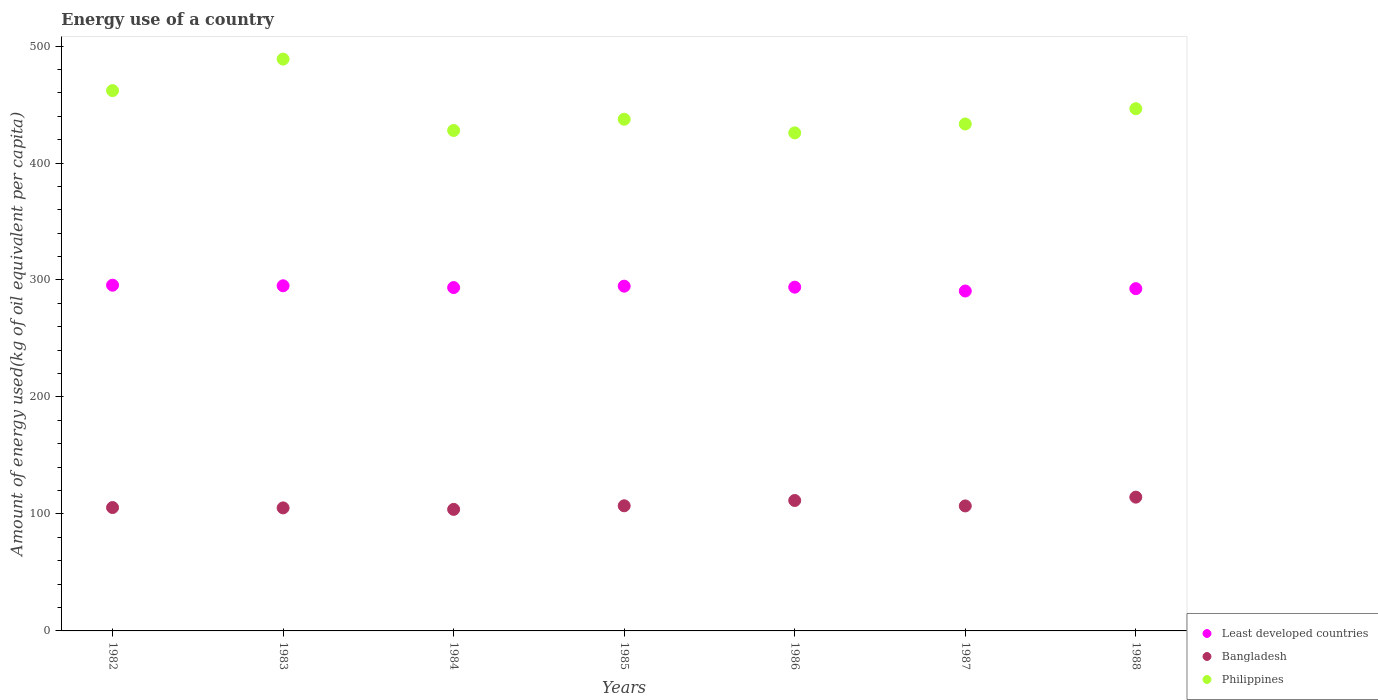How many different coloured dotlines are there?
Offer a terse response. 3. What is the amount of energy used in in Least developed countries in 1985?
Your answer should be very brief. 294.71. Across all years, what is the maximum amount of energy used in in Philippines?
Keep it short and to the point. 488.84. Across all years, what is the minimum amount of energy used in in Least developed countries?
Offer a very short reply. 290.58. In which year was the amount of energy used in in Bangladesh minimum?
Your answer should be compact. 1984. What is the total amount of energy used in in Philippines in the graph?
Provide a short and direct response. 3121.52. What is the difference between the amount of energy used in in Bangladesh in 1982 and that in 1985?
Make the answer very short. -1.5. What is the difference between the amount of energy used in in Philippines in 1988 and the amount of energy used in in Bangladesh in 1983?
Give a very brief answer. 341.26. What is the average amount of energy used in in Bangladesh per year?
Offer a terse response. 107.74. In the year 1984, what is the difference between the amount of energy used in in Bangladesh and amount of energy used in in Philippines?
Your answer should be very brief. -323.91. In how many years, is the amount of energy used in in Bangladesh greater than 320 kg?
Make the answer very short. 0. What is the ratio of the amount of energy used in in Least developed countries in 1983 to that in 1985?
Offer a terse response. 1. Is the difference between the amount of energy used in in Bangladesh in 1987 and 1988 greater than the difference between the amount of energy used in in Philippines in 1987 and 1988?
Keep it short and to the point. Yes. What is the difference between the highest and the second highest amount of energy used in in Bangladesh?
Provide a short and direct response. 2.87. What is the difference between the highest and the lowest amount of energy used in in Least developed countries?
Offer a very short reply. 4.97. Is it the case that in every year, the sum of the amount of energy used in in Bangladesh and amount of energy used in in Least developed countries  is greater than the amount of energy used in in Philippines?
Your response must be concise. No. Does the amount of energy used in in Least developed countries monotonically increase over the years?
Keep it short and to the point. No. How many years are there in the graph?
Keep it short and to the point. 7. What is the difference between two consecutive major ticks on the Y-axis?
Your response must be concise. 100. Are the values on the major ticks of Y-axis written in scientific E-notation?
Provide a succinct answer. No. How many legend labels are there?
Ensure brevity in your answer.  3. What is the title of the graph?
Provide a short and direct response. Energy use of a country. What is the label or title of the X-axis?
Make the answer very short. Years. What is the label or title of the Y-axis?
Your answer should be very brief. Amount of energy used(kg of oil equivalent per capita). What is the Amount of energy used(kg of oil equivalent per capita) of Least developed countries in 1982?
Ensure brevity in your answer.  295.55. What is the Amount of energy used(kg of oil equivalent per capita) of Bangladesh in 1982?
Your answer should be compact. 105.47. What is the Amount of energy used(kg of oil equivalent per capita) of Philippines in 1982?
Provide a succinct answer. 461.89. What is the Amount of energy used(kg of oil equivalent per capita) of Least developed countries in 1983?
Offer a very short reply. 295.06. What is the Amount of energy used(kg of oil equivalent per capita) of Bangladesh in 1983?
Ensure brevity in your answer.  105.17. What is the Amount of energy used(kg of oil equivalent per capita) in Philippines in 1983?
Provide a short and direct response. 488.84. What is the Amount of energy used(kg of oil equivalent per capita) of Least developed countries in 1984?
Offer a terse response. 293.51. What is the Amount of energy used(kg of oil equivalent per capita) in Bangladesh in 1984?
Provide a short and direct response. 103.9. What is the Amount of energy used(kg of oil equivalent per capita) in Philippines in 1984?
Ensure brevity in your answer.  427.81. What is the Amount of energy used(kg of oil equivalent per capita) in Least developed countries in 1985?
Your response must be concise. 294.71. What is the Amount of energy used(kg of oil equivalent per capita) in Bangladesh in 1985?
Ensure brevity in your answer.  106.97. What is the Amount of energy used(kg of oil equivalent per capita) in Philippines in 1985?
Make the answer very short. 437.41. What is the Amount of energy used(kg of oil equivalent per capita) of Least developed countries in 1986?
Offer a very short reply. 293.86. What is the Amount of energy used(kg of oil equivalent per capita) in Bangladesh in 1986?
Your response must be concise. 111.49. What is the Amount of energy used(kg of oil equivalent per capita) of Philippines in 1986?
Your answer should be very brief. 425.77. What is the Amount of energy used(kg of oil equivalent per capita) in Least developed countries in 1987?
Your answer should be very brief. 290.58. What is the Amount of energy used(kg of oil equivalent per capita) of Bangladesh in 1987?
Your response must be concise. 106.85. What is the Amount of energy used(kg of oil equivalent per capita) in Philippines in 1987?
Your response must be concise. 433.36. What is the Amount of energy used(kg of oil equivalent per capita) in Least developed countries in 1988?
Offer a very short reply. 292.6. What is the Amount of energy used(kg of oil equivalent per capita) in Bangladesh in 1988?
Ensure brevity in your answer.  114.36. What is the Amount of energy used(kg of oil equivalent per capita) in Philippines in 1988?
Provide a short and direct response. 446.44. Across all years, what is the maximum Amount of energy used(kg of oil equivalent per capita) of Least developed countries?
Offer a terse response. 295.55. Across all years, what is the maximum Amount of energy used(kg of oil equivalent per capita) of Bangladesh?
Provide a succinct answer. 114.36. Across all years, what is the maximum Amount of energy used(kg of oil equivalent per capita) in Philippines?
Your response must be concise. 488.84. Across all years, what is the minimum Amount of energy used(kg of oil equivalent per capita) in Least developed countries?
Your answer should be very brief. 290.58. Across all years, what is the minimum Amount of energy used(kg of oil equivalent per capita) of Bangladesh?
Provide a short and direct response. 103.9. Across all years, what is the minimum Amount of energy used(kg of oil equivalent per capita) of Philippines?
Your answer should be very brief. 425.77. What is the total Amount of energy used(kg of oil equivalent per capita) in Least developed countries in the graph?
Your answer should be very brief. 2055.87. What is the total Amount of energy used(kg of oil equivalent per capita) in Bangladesh in the graph?
Make the answer very short. 754.21. What is the total Amount of energy used(kg of oil equivalent per capita) of Philippines in the graph?
Offer a very short reply. 3121.52. What is the difference between the Amount of energy used(kg of oil equivalent per capita) in Least developed countries in 1982 and that in 1983?
Offer a terse response. 0.5. What is the difference between the Amount of energy used(kg of oil equivalent per capita) of Bangladesh in 1982 and that in 1983?
Ensure brevity in your answer.  0.3. What is the difference between the Amount of energy used(kg of oil equivalent per capita) of Philippines in 1982 and that in 1983?
Offer a terse response. -26.95. What is the difference between the Amount of energy used(kg of oil equivalent per capita) in Least developed countries in 1982 and that in 1984?
Provide a succinct answer. 2.04. What is the difference between the Amount of energy used(kg of oil equivalent per capita) of Bangladesh in 1982 and that in 1984?
Provide a succinct answer. 1.57. What is the difference between the Amount of energy used(kg of oil equivalent per capita) in Philippines in 1982 and that in 1984?
Provide a succinct answer. 34.08. What is the difference between the Amount of energy used(kg of oil equivalent per capita) in Least developed countries in 1982 and that in 1985?
Give a very brief answer. 0.84. What is the difference between the Amount of energy used(kg of oil equivalent per capita) in Bangladesh in 1982 and that in 1985?
Ensure brevity in your answer.  -1.5. What is the difference between the Amount of energy used(kg of oil equivalent per capita) of Philippines in 1982 and that in 1985?
Make the answer very short. 24.48. What is the difference between the Amount of energy used(kg of oil equivalent per capita) in Least developed countries in 1982 and that in 1986?
Provide a succinct answer. 1.69. What is the difference between the Amount of energy used(kg of oil equivalent per capita) in Bangladesh in 1982 and that in 1986?
Your answer should be compact. -6.02. What is the difference between the Amount of energy used(kg of oil equivalent per capita) in Philippines in 1982 and that in 1986?
Provide a succinct answer. 36.12. What is the difference between the Amount of energy used(kg of oil equivalent per capita) of Least developed countries in 1982 and that in 1987?
Provide a succinct answer. 4.97. What is the difference between the Amount of energy used(kg of oil equivalent per capita) in Bangladesh in 1982 and that in 1987?
Keep it short and to the point. -1.38. What is the difference between the Amount of energy used(kg of oil equivalent per capita) in Philippines in 1982 and that in 1987?
Provide a succinct answer. 28.53. What is the difference between the Amount of energy used(kg of oil equivalent per capita) in Least developed countries in 1982 and that in 1988?
Provide a short and direct response. 2.95. What is the difference between the Amount of energy used(kg of oil equivalent per capita) of Bangladesh in 1982 and that in 1988?
Offer a terse response. -8.89. What is the difference between the Amount of energy used(kg of oil equivalent per capita) of Philippines in 1982 and that in 1988?
Keep it short and to the point. 15.46. What is the difference between the Amount of energy used(kg of oil equivalent per capita) of Least developed countries in 1983 and that in 1984?
Keep it short and to the point. 1.54. What is the difference between the Amount of energy used(kg of oil equivalent per capita) in Bangladesh in 1983 and that in 1984?
Give a very brief answer. 1.27. What is the difference between the Amount of energy used(kg of oil equivalent per capita) in Philippines in 1983 and that in 1984?
Your answer should be very brief. 61.03. What is the difference between the Amount of energy used(kg of oil equivalent per capita) in Least developed countries in 1983 and that in 1985?
Give a very brief answer. 0.34. What is the difference between the Amount of energy used(kg of oil equivalent per capita) of Bangladesh in 1983 and that in 1985?
Ensure brevity in your answer.  -1.8. What is the difference between the Amount of energy used(kg of oil equivalent per capita) of Philippines in 1983 and that in 1985?
Keep it short and to the point. 51.42. What is the difference between the Amount of energy used(kg of oil equivalent per capita) in Least developed countries in 1983 and that in 1986?
Offer a terse response. 1.19. What is the difference between the Amount of energy used(kg of oil equivalent per capita) of Bangladesh in 1983 and that in 1986?
Offer a very short reply. -6.32. What is the difference between the Amount of energy used(kg of oil equivalent per capita) of Philippines in 1983 and that in 1986?
Provide a succinct answer. 63.07. What is the difference between the Amount of energy used(kg of oil equivalent per capita) of Least developed countries in 1983 and that in 1987?
Keep it short and to the point. 4.48. What is the difference between the Amount of energy used(kg of oil equivalent per capita) in Bangladesh in 1983 and that in 1987?
Make the answer very short. -1.68. What is the difference between the Amount of energy used(kg of oil equivalent per capita) of Philippines in 1983 and that in 1987?
Give a very brief answer. 55.48. What is the difference between the Amount of energy used(kg of oil equivalent per capita) in Least developed countries in 1983 and that in 1988?
Give a very brief answer. 2.45. What is the difference between the Amount of energy used(kg of oil equivalent per capita) of Bangladesh in 1983 and that in 1988?
Provide a short and direct response. -9.19. What is the difference between the Amount of energy used(kg of oil equivalent per capita) of Philippines in 1983 and that in 1988?
Your answer should be very brief. 42.4. What is the difference between the Amount of energy used(kg of oil equivalent per capita) in Least developed countries in 1984 and that in 1985?
Keep it short and to the point. -1.2. What is the difference between the Amount of energy used(kg of oil equivalent per capita) of Bangladesh in 1984 and that in 1985?
Make the answer very short. -3.07. What is the difference between the Amount of energy used(kg of oil equivalent per capita) of Philippines in 1984 and that in 1985?
Provide a short and direct response. -9.6. What is the difference between the Amount of energy used(kg of oil equivalent per capita) in Least developed countries in 1984 and that in 1986?
Keep it short and to the point. -0.35. What is the difference between the Amount of energy used(kg of oil equivalent per capita) of Bangladesh in 1984 and that in 1986?
Make the answer very short. -7.59. What is the difference between the Amount of energy used(kg of oil equivalent per capita) of Philippines in 1984 and that in 1986?
Offer a very short reply. 2.04. What is the difference between the Amount of energy used(kg of oil equivalent per capita) of Least developed countries in 1984 and that in 1987?
Ensure brevity in your answer.  2.94. What is the difference between the Amount of energy used(kg of oil equivalent per capita) of Bangladesh in 1984 and that in 1987?
Provide a succinct answer. -2.95. What is the difference between the Amount of energy used(kg of oil equivalent per capita) of Philippines in 1984 and that in 1987?
Your answer should be very brief. -5.55. What is the difference between the Amount of energy used(kg of oil equivalent per capita) of Least developed countries in 1984 and that in 1988?
Make the answer very short. 0.91. What is the difference between the Amount of energy used(kg of oil equivalent per capita) in Bangladesh in 1984 and that in 1988?
Provide a short and direct response. -10.46. What is the difference between the Amount of energy used(kg of oil equivalent per capita) in Philippines in 1984 and that in 1988?
Give a very brief answer. -18.62. What is the difference between the Amount of energy used(kg of oil equivalent per capita) of Least developed countries in 1985 and that in 1986?
Keep it short and to the point. 0.85. What is the difference between the Amount of energy used(kg of oil equivalent per capita) in Bangladesh in 1985 and that in 1986?
Provide a succinct answer. -4.53. What is the difference between the Amount of energy used(kg of oil equivalent per capita) in Philippines in 1985 and that in 1986?
Provide a short and direct response. 11.64. What is the difference between the Amount of energy used(kg of oil equivalent per capita) in Least developed countries in 1985 and that in 1987?
Make the answer very short. 4.14. What is the difference between the Amount of energy used(kg of oil equivalent per capita) of Bangladesh in 1985 and that in 1987?
Offer a very short reply. 0.12. What is the difference between the Amount of energy used(kg of oil equivalent per capita) in Philippines in 1985 and that in 1987?
Provide a succinct answer. 4.06. What is the difference between the Amount of energy used(kg of oil equivalent per capita) of Least developed countries in 1985 and that in 1988?
Your answer should be very brief. 2.11. What is the difference between the Amount of energy used(kg of oil equivalent per capita) of Bangladesh in 1985 and that in 1988?
Make the answer very short. -7.39. What is the difference between the Amount of energy used(kg of oil equivalent per capita) in Philippines in 1985 and that in 1988?
Your answer should be very brief. -9.02. What is the difference between the Amount of energy used(kg of oil equivalent per capita) of Least developed countries in 1986 and that in 1987?
Your response must be concise. 3.28. What is the difference between the Amount of energy used(kg of oil equivalent per capita) in Bangladesh in 1986 and that in 1987?
Your answer should be compact. 4.64. What is the difference between the Amount of energy used(kg of oil equivalent per capita) of Philippines in 1986 and that in 1987?
Offer a very short reply. -7.59. What is the difference between the Amount of energy used(kg of oil equivalent per capita) in Least developed countries in 1986 and that in 1988?
Give a very brief answer. 1.26. What is the difference between the Amount of energy used(kg of oil equivalent per capita) in Bangladesh in 1986 and that in 1988?
Keep it short and to the point. -2.87. What is the difference between the Amount of energy used(kg of oil equivalent per capita) in Philippines in 1986 and that in 1988?
Make the answer very short. -20.67. What is the difference between the Amount of energy used(kg of oil equivalent per capita) of Least developed countries in 1987 and that in 1988?
Provide a succinct answer. -2.03. What is the difference between the Amount of energy used(kg of oil equivalent per capita) of Bangladesh in 1987 and that in 1988?
Give a very brief answer. -7.51. What is the difference between the Amount of energy used(kg of oil equivalent per capita) in Philippines in 1987 and that in 1988?
Offer a very short reply. -13.08. What is the difference between the Amount of energy used(kg of oil equivalent per capita) of Least developed countries in 1982 and the Amount of energy used(kg of oil equivalent per capita) of Bangladesh in 1983?
Ensure brevity in your answer.  190.38. What is the difference between the Amount of energy used(kg of oil equivalent per capita) in Least developed countries in 1982 and the Amount of energy used(kg of oil equivalent per capita) in Philippines in 1983?
Make the answer very short. -193.29. What is the difference between the Amount of energy used(kg of oil equivalent per capita) of Bangladesh in 1982 and the Amount of energy used(kg of oil equivalent per capita) of Philippines in 1983?
Offer a very short reply. -383.36. What is the difference between the Amount of energy used(kg of oil equivalent per capita) in Least developed countries in 1982 and the Amount of energy used(kg of oil equivalent per capita) in Bangladesh in 1984?
Provide a short and direct response. 191.65. What is the difference between the Amount of energy used(kg of oil equivalent per capita) of Least developed countries in 1982 and the Amount of energy used(kg of oil equivalent per capita) of Philippines in 1984?
Give a very brief answer. -132.26. What is the difference between the Amount of energy used(kg of oil equivalent per capita) of Bangladesh in 1982 and the Amount of energy used(kg of oil equivalent per capita) of Philippines in 1984?
Your response must be concise. -322.34. What is the difference between the Amount of energy used(kg of oil equivalent per capita) of Least developed countries in 1982 and the Amount of energy used(kg of oil equivalent per capita) of Bangladesh in 1985?
Offer a very short reply. 188.58. What is the difference between the Amount of energy used(kg of oil equivalent per capita) in Least developed countries in 1982 and the Amount of energy used(kg of oil equivalent per capita) in Philippines in 1985?
Keep it short and to the point. -141.86. What is the difference between the Amount of energy used(kg of oil equivalent per capita) in Bangladesh in 1982 and the Amount of energy used(kg of oil equivalent per capita) in Philippines in 1985?
Your answer should be compact. -331.94. What is the difference between the Amount of energy used(kg of oil equivalent per capita) in Least developed countries in 1982 and the Amount of energy used(kg of oil equivalent per capita) in Bangladesh in 1986?
Offer a terse response. 184.06. What is the difference between the Amount of energy used(kg of oil equivalent per capita) in Least developed countries in 1982 and the Amount of energy used(kg of oil equivalent per capita) in Philippines in 1986?
Ensure brevity in your answer.  -130.22. What is the difference between the Amount of energy used(kg of oil equivalent per capita) in Bangladesh in 1982 and the Amount of energy used(kg of oil equivalent per capita) in Philippines in 1986?
Make the answer very short. -320.3. What is the difference between the Amount of energy used(kg of oil equivalent per capita) of Least developed countries in 1982 and the Amount of energy used(kg of oil equivalent per capita) of Bangladesh in 1987?
Give a very brief answer. 188.7. What is the difference between the Amount of energy used(kg of oil equivalent per capita) of Least developed countries in 1982 and the Amount of energy used(kg of oil equivalent per capita) of Philippines in 1987?
Ensure brevity in your answer.  -137.81. What is the difference between the Amount of energy used(kg of oil equivalent per capita) in Bangladesh in 1982 and the Amount of energy used(kg of oil equivalent per capita) in Philippines in 1987?
Offer a terse response. -327.88. What is the difference between the Amount of energy used(kg of oil equivalent per capita) in Least developed countries in 1982 and the Amount of energy used(kg of oil equivalent per capita) in Bangladesh in 1988?
Provide a short and direct response. 181.19. What is the difference between the Amount of energy used(kg of oil equivalent per capita) in Least developed countries in 1982 and the Amount of energy used(kg of oil equivalent per capita) in Philippines in 1988?
Make the answer very short. -150.88. What is the difference between the Amount of energy used(kg of oil equivalent per capita) in Bangladesh in 1982 and the Amount of energy used(kg of oil equivalent per capita) in Philippines in 1988?
Provide a succinct answer. -340.96. What is the difference between the Amount of energy used(kg of oil equivalent per capita) in Least developed countries in 1983 and the Amount of energy used(kg of oil equivalent per capita) in Bangladesh in 1984?
Offer a very short reply. 191.16. What is the difference between the Amount of energy used(kg of oil equivalent per capita) in Least developed countries in 1983 and the Amount of energy used(kg of oil equivalent per capita) in Philippines in 1984?
Provide a succinct answer. -132.76. What is the difference between the Amount of energy used(kg of oil equivalent per capita) in Bangladesh in 1983 and the Amount of energy used(kg of oil equivalent per capita) in Philippines in 1984?
Make the answer very short. -322.64. What is the difference between the Amount of energy used(kg of oil equivalent per capita) of Least developed countries in 1983 and the Amount of energy used(kg of oil equivalent per capita) of Bangladesh in 1985?
Ensure brevity in your answer.  188.09. What is the difference between the Amount of energy used(kg of oil equivalent per capita) of Least developed countries in 1983 and the Amount of energy used(kg of oil equivalent per capita) of Philippines in 1985?
Offer a terse response. -142.36. What is the difference between the Amount of energy used(kg of oil equivalent per capita) of Bangladesh in 1983 and the Amount of energy used(kg of oil equivalent per capita) of Philippines in 1985?
Your answer should be very brief. -332.24. What is the difference between the Amount of energy used(kg of oil equivalent per capita) in Least developed countries in 1983 and the Amount of energy used(kg of oil equivalent per capita) in Bangladesh in 1986?
Ensure brevity in your answer.  183.56. What is the difference between the Amount of energy used(kg of oil equivalent per capita) of Least developed countries in 1983 and the Amount of energy used(kg of oil equivalent per capita) of Philippines in 1986?
Provide a short and direct response. -130.71. What is the difference between the Amount of energy used(kg of oil equivalent per capita) in Bangladesh in 1983 and the Amount of energy used(kg of oil equivalent per capita) in Philippines in 1986?
Give a very brief answer. -320.6. What is the difference between the Amount of energy used(kg of oil equivalent per capita) in Least developed countries in 1983 and the Amount of energy used(kg of oil equivalent per capita) in Bangladesh in 1987?
Your answer should be compact. 188.21. What is the difference between the Amount of energy used(kg of oil equivalent per capita) of Least developed countries in 1983 and the Amount of energy used(kg of oil equivalent per capita) of Philippines in 1987?
Offer a terse response. -138.3. What is the difference between the Amount of energy used(kg of oil equivalent per capita) in Bangladesh in 1983 and the Amount of energy used(kg of oil equivalent per capita) in Philippines in 1987?
Make the answer very short. -328.19. What is the difference between the Amount of energy used(kg of oil equivalent per capita) in Least developed countries in 1983 and the Amount of energy used(kg of oil equivalent per capita) in Bangladesh in 1988?
Provide a succinct answer. 180.7. What is the difference between the Amount of energy used(kg of oil equivalent per capita) in Least developed countries in 1983 and the Amount of energy used(kg of oil equivalent per capita) in Philippines in 1988?
Ensure brevity in your answer.  -151.38. What is the difference between the Amount of energy used(kg of oil equivalent per capita) of Bangladesh in 1983 and the Amount of energy used(kg of oil equivalent per capita) of Philippines in 1988?
Provide a short and direct response. -341.26. What is the difference between the Amount of energy used(kg of oil equivalent per capita) of Least developed countries in 1984 and the Amount of energy used(kg of oil equivalent per capita) of Bangladesh in 1985?
Offer a very short reply. 186.55. What is the difference between the Amount of energy used(kg of oil equivalent per capita) of Least developed countries in 1984 and the Amount of energy used(kg of oil equivalent per capita) of Philippines in 1985?
Offer a very short reply. -143.9. What is the difference between the Amount of energy used(kg of oil equivalent per capita) in Bangladesh in 1984 and the Amount of energy used(kg of oil equivalent per capita) in Philippines in 1985?
Ensure brevity in your answer.  -333.51. What is the difference between the Amount of energy used(kg of oil equivalent per capita) of Least developed countries in 1984 and the Amount of energy used(kg of oil equivalent per capita) of Bangladesh in 1986?
Your response must be concise. 182.02. What is the difference between the Amount of energy used(kg of oil equivalent per capita) of Least developed countries in 1984 and the Amount of energy used(kg of oil equivalent per capita) of Philippines in 1986?
Offer a terse response. -132.26. What is the difference between the Amount of energy used(kg of oil equivalent per capita) in Bangladesh in 1984 and the Amount of energy used(kg of oil equivalent per capita) in Philippines in 1986?
Ensure brevity in your answer.  -321.87. What is the difference between the Amount of energy used(kg of oil equivalent per capita) of Least developed countries in 1984 and the Amount of energy used(kg of oil equivalent per capita) of Bangladesh in 1987?
Your answer should be compact. 186.66. What is the difference between the Amount of energy used(kg of oil equivalent per capita) of Least developed countries in 1984 and the Amount of energy used(kg of oil equivalent per capita) of Philippines in 1987?
Your answer should be compact. -139.84. What is the difference between the Amount of energy used(kg of oil equivalent per capita) in Bangladesh in 1984 and the Amount of energy used(kg of oil equivalent per capita) in Philippines in 1987?
Your response must be concise. -329.46. What is the difference between the Amount of energy used(kg of oil equivalent per capita) in Least developed countries in 1984 and the Amount of energy used(kg of oil equivalent per capita) in Bangladesh in 1988?
Offer a very short reply. 179.16. What is the difference between the Amount of energy used(kg of oil equivalent per capita) in Least developed countries in 1984 and the Amount of energy used(kg of oil equivalent per capita) in Philippines in 1988?
Provide a short and direct response. -152.92. What is the difference between the Amount of energy used(kg of oil equivalent per capita) in Bangladesh in 1984 and the Amount of energy used(kg of oil equivalent per capita) in Philippines in 1988?
Keep it short and to the point. -342.54. What is the difference between the Amount of energy used(kg of oil equivalent per capita) in Least developed countries in 1985 and the Amount of energy used(kg of oil equivalent per capita) in Bangladesh in 1986?
Offer a very short reply. 183.22. What is the difference between the Amount of energy used(kg of oil equivalent per capita) of Least developed countries in 1985 and the Amount of energy used(kg of oil equivalent per capita) of Philippines in 1986?
Provide a succinct answer. -131.06. What is the difference between the Amount of energy used(kg of oil equivalent per capita) in Bangladesh in 1985 and the Amount of energy used(kg of oil equivalent per capita) in Philippines in 1986?
Your response must be concise. -318.8. What is the difference between the Amount of energy used(kg of oil equivalent per capita) of Least developed countries in 1985 and the Amount of energy used(kg of oil equivalent per capita) of Bangladesh in 1987?
Offer a terse response. 187.86. What is the difference between the Amount of energy used(kg of oil equivalent per capita) of Least developed countries in 1985 and the Amount of energy used(kg of oil equivalent per capita) of Philippines in 1987?
Provide a short and direct response. -138.65. What is the difference between the Amount of energy used(kg of oil equivalent per capita) in Bangladesh in 1985 and the Amount of energy used(kg of oil equivalent per capita) in Philippines in 1987?
Offer a very short reply. -326.39. What is the difference between the Amount of energy used(kg of oil equivalent per capita) in Least developed countries in 1985 and the Amount of energy used(kg of oil equivalent per capita) in Bangladesh in 1988?
Offer a terse response. 180.35. What is the difference between the Amount of energy used(kg of oil equivalent per capita) of Least developed countries in 1985 and the Amount of energy used(kg of oil equivalent per capita) of Philippines in 1988?
Offer a terse response. -151.72. What is the difference between the Amount of energy used(kg of oil equivalent per capita) in Bangladesh in 1985 and the Amount of energy used(kg of oil equivalent per capita) in Philippines in 1988?
Provide a short and direct response. -339.47. What is the difference between the Amount of energy used(kg of oil equivalent per capita) of Least developed countries in 1986 and the Amount of energy used(kg of oil equivalent per capita) of Bangladesh in 1987?
Provide a short and direct response. 187.01. What is the difference between the Amount of energy used(kg of oil equivalent per capita) in Least developed countries in 1986 and the Amount of energy used(kg of oil equivalent per capita) in Philippines in 1987?
Your response must be concise. -139.5. What is the difference between the Amount of energy used(kg of oil equivalent per capita) of Bangladesh in 1986 and the Amount of energy used(kg of oil equivalent per capita) of Philippines in 1987?
Offer a very short reply. -321.86. What is the difference between the Amount of energy used(kg of oil equivalent per capita) in Least developed countries in 1986 and the Amount of energy used(kg of oil equivalent per capita) in Bangladesh in 1988?
Provide a short and direct response. 179.5. What is the difference between the Amount of energy used(kg of oil equivalent per capita) of Least developed countries in 1986 and the Amount of energy used(kg of oil equivalent per capita) of Philippines in 1988?
Provide a short and direct response. -152.57. What is the difference between the Amount of energy used(kg of oil equivalent per capita) of Bangladesh in 1986 and the Amount of energy used(kg of oil equivalent per capita) of Philippines in 1988?
Give a very brief answer. -334.94. What is the difference between the Amount of energy used(kg of oil equivalent per capita) in Least developed countries in 1987 and the Amount of energy used(kg of oil equivalent per capita) in Bangladesh in 1988?
Offer a very short reply. 176.22. What is the difference between the Amount of energy used(kg of oil equivalent per capita) of Least developed countries in 1987 and the Amount of energy used(kg of oil equivalent per capita) of Philippines in 1988?
Provide a short and direct response. -155.86. What is the difference between the Amount of energy used(kg of oil equivalent per capita) of Bangladesh in 1987 and the Amount of energy used(kg of oil equivalent per capita) of Philippines in 1988?
Provide a succinct answer. -339.59. What is the average Amount of energy used(kg of oil equivalent per capita) of Least developed countries per year?
Make the answer very short. 293.7. What is the average Amount of energy used(kg of oil equivalent per capita) in Bangladesh per year?
Your answer should be very brief. 107.74. What is the average Amount of energy used(kg of oil equivalent per capita) in Philippines per year?
Keep it short and to the point. 445.93. In the year 1982, what is the difference between the Amount of energy used(kg of oil equivalent per capita) in Least developed countries and Amount of energy used(kg of oil equivalent per capita) in Bangladesh?
Ensure brevity in your answer.  190.08. In the year 1982, what is the difference between the Amount of energy used(kg of oil equivalent per capita) of Least developed countries and Amount of energy used(kg of oil equivalent per capita) of Philippines?
Ensure brevity in your answer.  -166.34. In the year 1982, what is the difference between the Amount of energy used(kg of oil equivalent per capita) of Bangladesh and Amount of energy used(kg of oil equivalent per capita) of Philippines?
Make the answer very short. -356.42. In the year 1983, what is the difference between the Amount of energy used(kg of oil equivalent per capita) of Least developed countries and Amount of energy used(kg of oil equivalent per capita) of Bangladesh?
Offer a very short reply. 189.88. In the year 1983, what is the difference between the Amount of energy used(kg of oil equivalent per capita) of Least developed countries and Amount of energy used(kg of oil equivalent per capita) of Philippines?
Offer a very short reply. -193.78. In the year 1983, what is the difference between the Amount of energy used(kg of oil equivalent per capita) in Bangladesh and Amount of energy used(kg of oil equivalent per capita) in Philippines?
Give a very brief answer. -383.67. In the year 1984, what is the difference between the Amount of energy used(kg of oil equivalent per capita) of Least developed countries and Amount of energy used(kg of oil equivalent per capita) of Bangladesh?
Your answer should be compact. 189.62. In the year 1984, what is the difference between the Amount of energy used(kg of oil equivalent per capita) in Least developed countries and Amount of energy used(kg of oil equivalent per capita) in Philippines?
Offer a very short reply. -134.3. In the year 1984, what is the difference between the Amount of energy used(kg of oil equivalent per capita) in Bangladesh and Amount of energy used(kg of oil equivalent per capita) in Philippines?
Your answer should be compact. -323.91. In the year 1985, what is the difference between the Amount of energy used(kg of oil equivalent per capita) in Least developed countries and Amount of energy used(kg of oil equivalent per capita) in Bangladesh?
Make the answer very short. 187.74. In the year 1985, what is the difference between the Amount of energy used(kg of oil equivalent per capita) of Least developed countries and Amount of energy used(kg of oil equivalent per capita) of Philippines?
Ensure brevity in your answer.  -142.7. In the year 1985, what is the difference between the Amount of energy used(kg of oil equivalent per capita) in Bangladesh and Amount of energy used(kg of oil equivalent per capita) in Philippines?
Ensure brevity in your answer.  -330.45. In the year 1986, what is the difference between the Amount of energy used(kg of oil equivalent per capita) in Least developed countries and Amount of energy used(kg of oil equivalent per capita) in Bangladesh?
Your answer should be very brief. 182.37. In the year 1986, what is the difference between the Amount of energy used(kg of oil equivalent per capita) of Least developed countries and Amount of energy used(kg of oil equivalent per capita) of Philippines?
Provide a succinct answer. -131.91. In the year 1986, what is the difference between the Amount of energy used(kg of oil equivalent per capita) of Bangladesh and Amount of energy used(kg of oil equivalent per capita) of Philippines?
Keep it short and to the point. -314.28. In the year 1987, what is the difference between the Amount of energy used(kg of oil equivalent per capita) in Least developed countries and Amount of energy used(kg of oil equivalent per capita) in Bangladesh?
Offer a terse response. 183.73. In the year 1987, what is the difference between the Amount of energy used(kg of oil equivalent per capita) of Least developed countries and Amount of energy used(kg of oil equivalent per capita) of Philippines?
Provide a short and direct response. -142.78. In the year 1987, what is the difference between the Amount of energy used(kg of oil equivalent per capita) of Bangladesh and Amount of energy used(kg of oil equivalent per capita) of Philippines?
Give a very brief answer. -326.51. In the year 1988, what is the difference between the Amount of energy used(kg of oil equivalent per capita) in Least developed countries and Amount of energy used(kg of oil equivalent per capita) in Bangladesh?
Ensure brevity in your answer.  178.24. In the year 1988, what is the difference between the Amount of energy used(kg of oil equivalent per capita) in Least developed countries and Amount of energy used(kg of oil equivalent per capita) in Philippines?
Provide a succinct answer. -153.83. In the year 1988, what is the difference between the Amount of energy used(kg of oil equivalent per capita) of Bangladesh and Amount of energy used(kg of oil equivalent per capita) of Philippines?
Your response must be concise. -332.08. What is the ratio of the Amount of energy used(kg of oil equivalent per capita) of Least developed countries in 1982 to that in 1983?
Give a very brief answer. 1. What is the ratio of the Amount of energy used(kg of oil equivalent per capita) of Bangladesh in 1982 to that in 1983?
Make the answer very short. 1. What is the ratio of the Amount of energy used(kg of oil equivalent per capita) in Philippines in 1982 to that in 1983?
Offer a terse response. 0.94. What is the ratio of the Amount of energy used(kg of oil equivalent per capita) of Least developed countries in 1982 to that in 1984?
Offer a terse response. 1.01. What is the ratio of the Amount of energy used(kg of oil equivalent per capita) in Bangladesh in 1982 to that in 1984?
Your answer should be compact. 1.02. What is the ratio of the Amount of energy used(kg of oil equivalent per capita) of Philippines in 1982 to that in 1984?
Make the answer very short. 1.08. What is the ratio of the Amount of energy used(kg of oil equivalent per capita) in Bangladesh in 1982 to that in 1985?
Offer a terse response. 0.99. What is the ratio of the Amount of energy used(kg of oil equivalent per capita) in Philippines in 1982 to that in 1985?
Give a very brief answer. 1.06. What is the ratio of the Amount of energy used(kg of oil equivalent per capita) in Least developed countries in 1982 to that in 1986?
Your answer should be compact. 1.01. What is the ratio of the Amount of energy used(kg of oil equivalent per capita) of Bangladesh in 1982 to that in 1986?
Ensure brevity in your answer.  0.95. What is the ratio of the Amount of energy used(kg of oil equivalent per capita) of Philippines in 1982 to that in 1986?
Offer a terse response. 1.08. What is the ratio of the Amount of energy used(kg of oil equivalent per capita) in Least developed countries in 1982 to that in 1987?
Make the answer very short. 1.02. What is the ratio of the Amount of energy used(kg of oil equivalent per capita) in Bangladesh in 1982 to that in 1987?
Ensure brevity in your answer.  0.99. What is the ratio of the Amount of energy used(kg of oil equivalent per capita) in Philippines in 1982 to that in 1987?
Offer a very short reply. 1.07. What is the ratio of the Amount of energy used(kg of oil equivalent per capita) in Least developed countries in 1982 to that in 1988?
Your response must be concise. 1.01. What is the ratio of the Amount of energy used(kg of oil equivalent per capita) of Bangladesh in 1982 to that in 1988?
Offer a very short reply. 0.92. What is the ratio of the Amount of energy used(kg of oil equivalent per capita) in Philippines in 1982 to that in 1988?
Ensure brevity in your answer.  1.03. What is the ratio of the Amount of energy used(kg of oil equivalent per capita) in Bangladesh in 1983 to that in 1984?
Offer a very short reply. 1.01. What is the ratio of the Amount of energy used(kg of oil equivalent per capita) of Philippines in 1983 to that in 1984?
Provide a succinct answer. 1.14. What is the ratio of the Amount of energy used(kg of oil equivalent per capita) of Bangladesh in 1983 to that in 1985?
Your answer should be very brief. 0.98. What is the ratio of the Amount of energy used(kg of oil equivalent per capita) in Philippines in 1983 to that in 1985?
Your answer should be compact. 1.12. What is the ratio of the Amount of energy used(kg of oil equivalent per capita) in Least developed countries in 1983 to that in 1986?
Make the answer very short. 1. What is the ratio of the Amount of energy used(kg of oil equivalent per capita) of Bangladesh in 1983 to that in 1986?
Your response must be concise. 0.94. What is the ratio of the Amount of energy used(kg of oil equivalent per capita) of Philippines in 1983 to that in 1986?
Your response must be concise. 1.15. What is the ratio of the Amount of energy used(kg of oil equivalent per capita) in Least developed countries in 1983 to that in 1987?
Your answer should be very brief. 1.02. What is the ratio of the Amount of energy used(kg of oil equivalent per capita) of Bangladesh in 1983 to that in 1987?
Provide a short and direct response. 0.98. What is the ratio of the Amount of energy used(kg of oil equivalent per capita) of Philippines in 1983 to that in 1987?
Provide a succinct answer. 1.13. What is the ratio of the Amount of energy used(kg of oil equivalent per capita) in Least developed countries in 1983 to that in 1988?
Offer a very short reply. 1.01. What is the ratio of the Amount of energy used(kg of oil equivalent per capita) in Bangladesh in 1983 to that in 1988?
Provide a succinct answer. 0.92. What is the ratio of the Amount of energy used(kg of oil equivalent per capita) in Philippines in 1983 to that in 1988?
Keep it short and to the point. 1.09. What is the ratio of the Amount of energy used(kg of oil equivalent per capita) of Least developed countries in 1984 to that in 1985?
Make the answer very short. 1. What is the ratio of the Amount of energy used(kg of oil equivalent per capita) of Bangladesh in 1984 to that in 1985?
Provide a short and direct response. 0.97. What is the ratio of the Amount of energy used(kg of oil equivalent per capita) in Least developed countries in 1984 to that in 1986?
Provide a succinct answer. 1. What is the ratio of the Amount of energy used(kg of oil equivalent per capita) of Bangladesh in 1984 to that in 1986?
Your answer should be very brief. 0.93. What is the ratio of the Amount of energy used(kg of oil equivalent per capita) of Least developed countries in 1984 to that in 1987?
Provide a short and direct response. 1.01. What is the ratio of the Amount of energy used(kg of oil equivalent per capita) of Bangladesh in 1984 to that in 1987?
Your answer should be very brief. 0.97. What is the ratio of the Amount of energy used(kg of oil equivalent per capita) of Philippines in 1984 to that in 1987?
Make the answer very short. 0.99. What is the ratio of the Amount of energy used(kg of oil equivalent per capita) in Least developed countries in 1984 to that in 1988?
Your answer should be compact. 1. What is the ratio of the Amount of energy used(kg of oil equivalent per capita) in Bangladesh in 1984 to that in 1988?
Your answer should be very brief. 0.91. What is the ratio of the Amount of energy used(kg of oil equivalent per capita) in Philippines in 1984 to that in 1988?
Provide a succinct answer. 0.96. What is the ratio of the Amount of energy used(kg of oil equivalent per capita) of Bangladesh in 1985 to that in 1986?
Your response must be concise. 0.96. What is the ratio of the Amount of energy used(kg of oil equivalent per capita) of Philippines in 1985 to that in 1986?
Provide a succinct answer. 1.03. What is the ratio of the Amount of energy used(kg of oil equivalent per capita) in Least developed countries in 1985 to that in 1987?
Ensure brevity in your answer.  1.01. What is the ratio of the Amount of energy used(kg of oil equivalent per capita) in Philippines in 1985 to that in 1987?
Ensure brevity in your answer.  1.01. What is the ratio of the Amount of energy used(kg of oil equivalent per capita) of Least developed countries in 1985 to that in 1988?
Provide a short and direct response. 1.01. What is the ratio of the Amount of energy used(kg of oil equivalent per capita) of Bangladesh in 1985 to that in 1988?
Make the answer very short. 0.94. What is the ratio of the Amount of energy used(kg of oil equivalent per capita) in Philippines in 1985 to that in 1988?
Ensure brevity in your answer.  0.98. What is the ratio of the Amount of energy used(kg of oil equivalent per capita) of Least developed countries in 1986 to that in 1987?
Make the answer very short. 1.01. What is the ratio of the Amount of energy used(kg of oil equivalent per capita) in Bangladesh in 1986 to that in 1987?
Make the answer very short. 1.04. What is the ratio of the Amount of energy used(kg of oil equivalent per capita) in Philippines in 1986 to that in 1987?
Provide a short and direct response. 0.98. What is the ratio of the Amount of energy used(kg of oil equivalent per capita) in Least developed countries in 1986 to that in 1988?
Provide a short and direct response. 1. What is the ratio of the Amount of energy used(kg of oil equivalent per capita) of Bangladesh in 1986 to that in 1988?
Offer a very short reply. 0.97. What is the ratio of the Amount of energy used(kg of oil equivalent per capita) of Philippines in 1986 to that in 1988?
Provide a short and direct response. 0.95. What is the ratio of the Amount of energy used(kg of oil equivalent per capita) in Bangladesh in 1987 to that in 1988?
Your response must be concise. 0.93. What is the ratio of the Amount of energy used(kg of oil equivalent per capita) in Philippines in 1987 to that in 1988?
Give a very brief answer. 0.97. What is the difference between the highest and the second highest Amount of energy used(kg of oil equivalent per capita) of Least developed countries?
Your answer should be compact. 0.5. What is the difference between the highest and the second highest Amount of energy used(kg of oil equivalent per capita) of Bangladesh?
Keep it short and to the point. 2.87. What is the difference between the highest and the second highest Amount of energy used(kg of oil equivalent per capita) in Philippines?
Your answer should be very brief. 26.95. What is the difference between the highest and the lowest Amount of energy used(kg of oil equivalent per capita) of Least developed countries?
Keep it short and to the point. 4.97. What is the difference between the highest and the lowest Amount of energy used(kg of oil equivalent per capita) of Bangladesh?
Make the answer very short. 10.46. What is the difference between the highest and the lowest Amount of energy used(kg of oil equivalent per capita) of Philippines?
Provide a short and direct response. 63.07. 